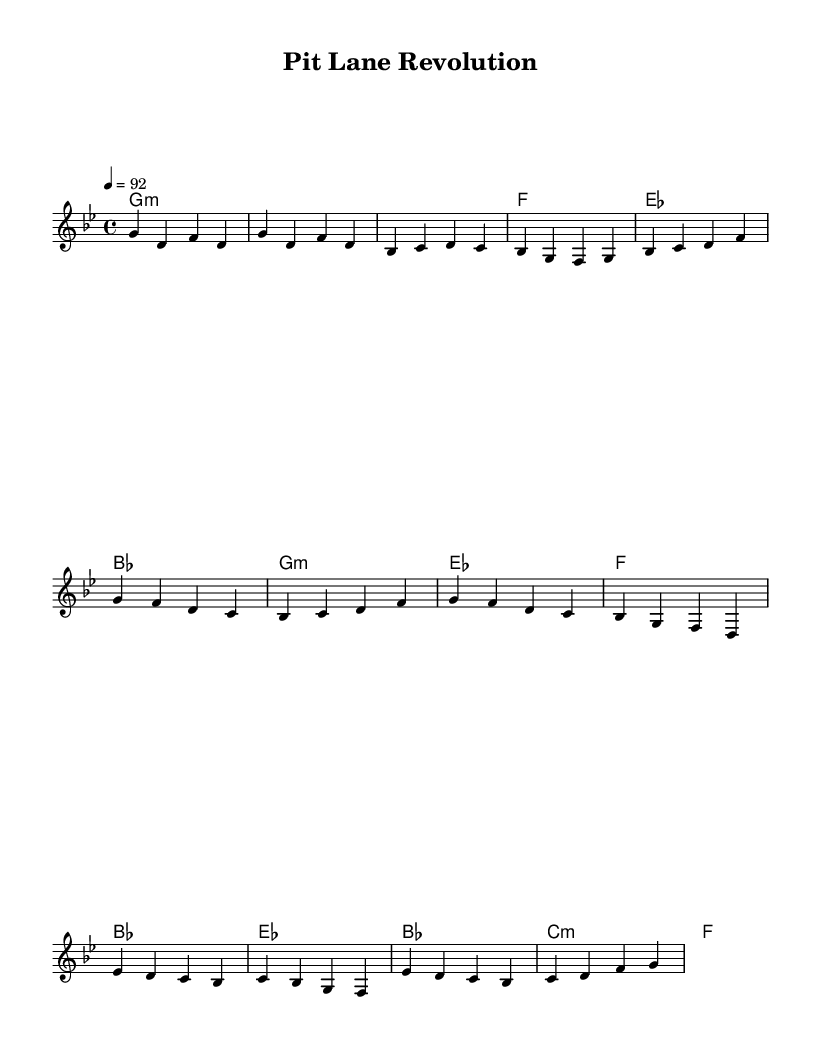What is the key signature of this music? The key signature is G minor, indicated by the one flat (B♭) found at the beginning of the staff.
Answer: G minor What is the time signature of this music? The time signature is 4/4, shown at the beginning of the score, indicating four beats per measure.
Answer: 4/4 What is the tempo marking for this piece? The tempo marking is a quarter note equals 92 beats per minute, noted at the beginning under the global settings.
Answer: 92 How many measures are in the intro section? The intro consists of 2 measures as seen from the first two lines of the melody, which contain distinct musical phrases.
Answer: 2 What are the primary chords used in the chorus? The primary chords in the chorus are G minor, E♭ major, F major, and B♭ major, all indicated in the harmonies section corresponding to the melody's phrases.
Answer: G minor, E♭ major, F major, B♭ major What is the melodic range of the lead voice? The melodic range of the lead voice spans from G4 down to C5, based on the note heights within the melodic line.
Answer: G4 to C5 What thematic concept is represented in the lyrics of this Hip Hop track? The thematic concept revolves around automotive innovation and engineering breakthroughs, reflecting the cultural elements of Hip Hop combined with a technical perspective typical of automotive discourse.
Answer: Automotive innovation and engineering breakthroughs 